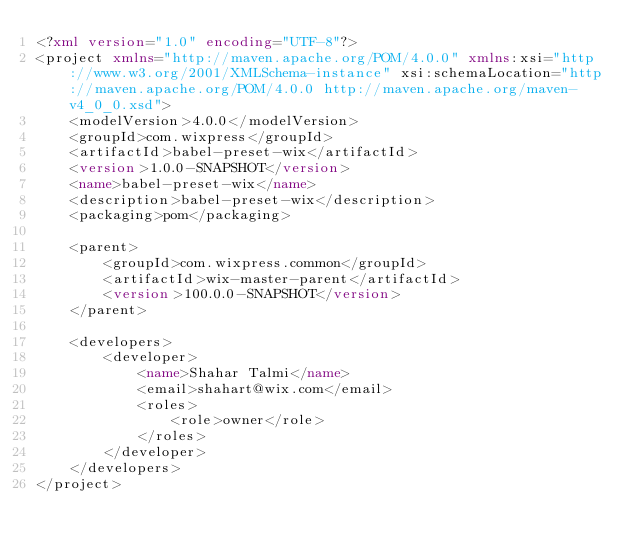<code> <loc_0><loc_0><loc_500><loc_500><_XML_><?xml version="1.0" encoding="UTF-8"?>
<project xmlns="http://maven.apache.org/POM/4.0.0" xmlns:xsi="http://www.w3.org/2001/XMLSchema-instance" xsi:schemaLocation="http://maven.apache.org/POM/4.0.0 http://maven.apache.org/maven-v4_0_0.xsd">
    <modelVersion>4.0.0</modelVersion>
    <groupId>com.wixpress</groupId>
    <artifactId>babel-preset-wix</artifactId>
    <version>1.0.0-SNAPSHOT</version>
    <name>babel-preset-wix</name>
    <description>babel-preset-wix</description>
    <packaging>pom</packaging>

    <parent>
        <groupId>com.wixpress.common</groupId>
        <artifactId>wix-master-parent</artifactId>
        <version>100.0.0-SNAPSHOT</version>
    </parent>

    <developers>
        <developer>
            <name>Shahar Talmi</name>
            <email>shahart@wix.com</email>
            <roles>
                <role>owner</role>
            </roles>
        </developer>
    </developers>
</project>
 
</code> 